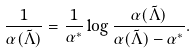Convert formula to latex. <formula><loc_0><loc_0><loc_500><loc_500>\frac { 1 } { \alpha ( \tilde { \Lambda } ) } = \frac { 1 } { \alpha ^ { * } } \log { \frac { \alpha ( \tilde { \Lambda } ) } { \alpha ( \tilde { \Lambda } ) - \alpha ^ { * } } } .</formula> 